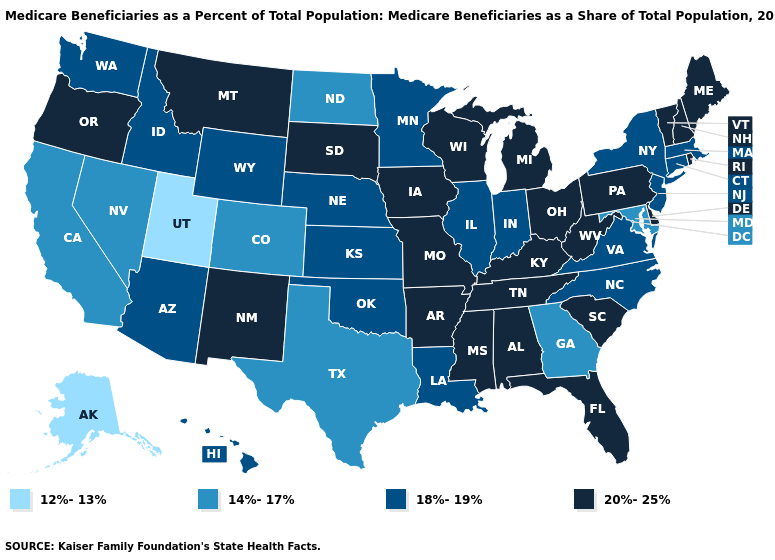Name the states that have a value in the range 12%-13%?
Keep it brief. Alaska, Utah. Name the states that have a value in the range 18%-19%?
Keep it brief. Arizona, Connecticut, Hawaii, Idaho, Illinois, Indiana, Kansas, Louisiana, Massachusetts, Minnesota, Nebraska, New Jersey, New York, North Carolina, Oklahoma, Virginia, Washington, Wyoming. Does Wisconsin have the lowest value in the USA?
Quick response, please. No. What is the value of Wyoming?
Give a very brief answer. 18%-19%. Is the legend a continuous bar?
Give a very brief answer. No. Name the states that have a value in the range 14%-17%?
Concise answer only. California, Colorado, Georgia, Maryland, Nevada, North Dakota, Texas. Among the states that border Colorado , does New Mexico have the highest value?
Give a very brief answer. Yes. What is the highest value in states that border Wyoming?
Answer briefly. 20%-25%. Name the states that have a value in the range 18%-19%?
Be succinct. Arizona, Connecticut, Hawaii, Idaho, Illinois, Indiana, Kansas, Louisiana, Massachusetts, Minnesota, Nebraska, New Jersey, New York, North Carolina, Oklahoma, Virginia, Washington, Wyoming. Name the states that have a value in the range 12%-13%?
Give a very brief answer. Alaska, Utah. Which states have the lowest value in the Northeast?
Write a very short answer. Connecticut, Massachusetts, New Jersey, New York. What is the value of Hawaii?
Short answer required. 18%-19%. What is the value of Nevada?
Be succinct. 14%-17%. Does Indiana have the highest value in the USA?
Short answer required. No. Which states have the lowest value in the MidWest?
Concise answer only. North Dakota. 